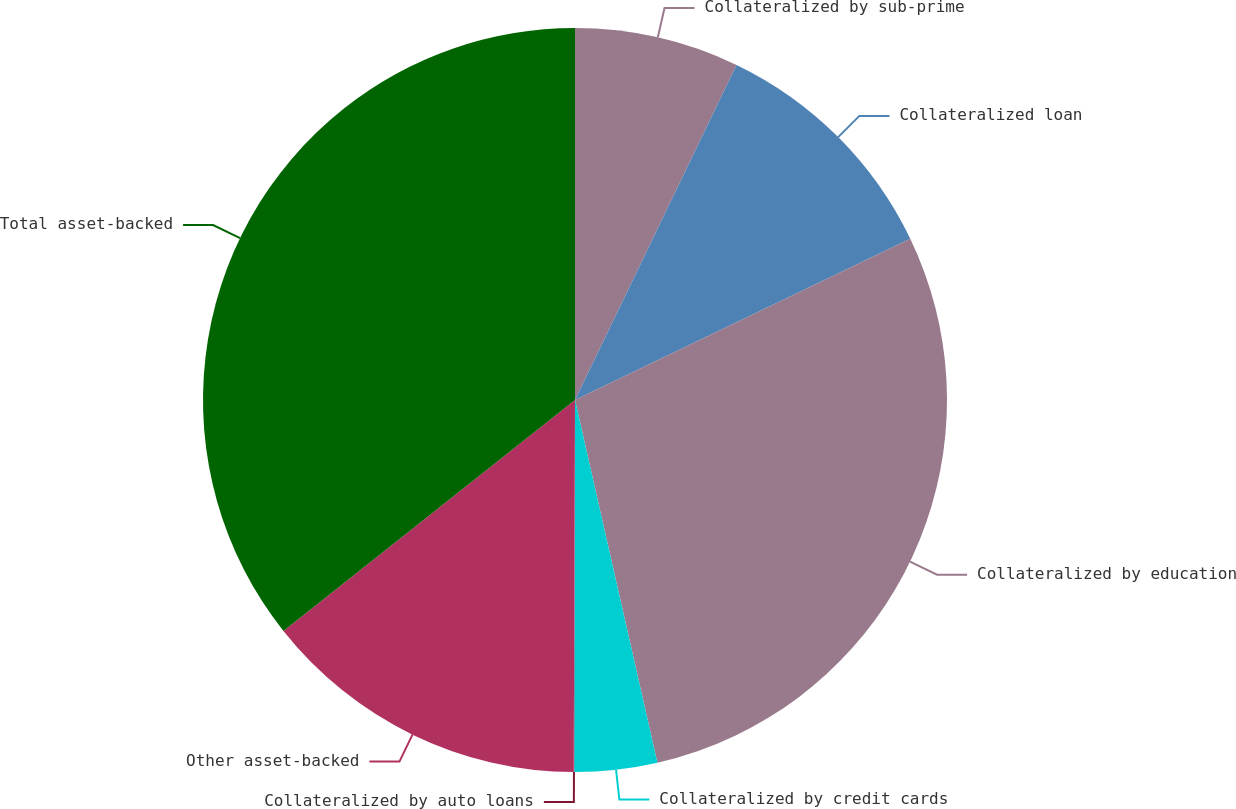Convert chart to OTSL. <chart><loc_0><loc_0><loc_500><loc_500><pie_chart><fcel>Collateralized by sub-prime<fcel>Collateralized loan<fcel>Collateralized by education<fcel>Collateralized by credit cards<fcel>Collateralized by auto loans<fcel>Other asset-backed<fcel>Total asset-backed<nl><fcel>7.15%<fcel>10.72%<fcel>28.58%<fcel>3.59%<fcel>0.02%<fcel>14.28%<fcel>35.67%<nl></chart> 